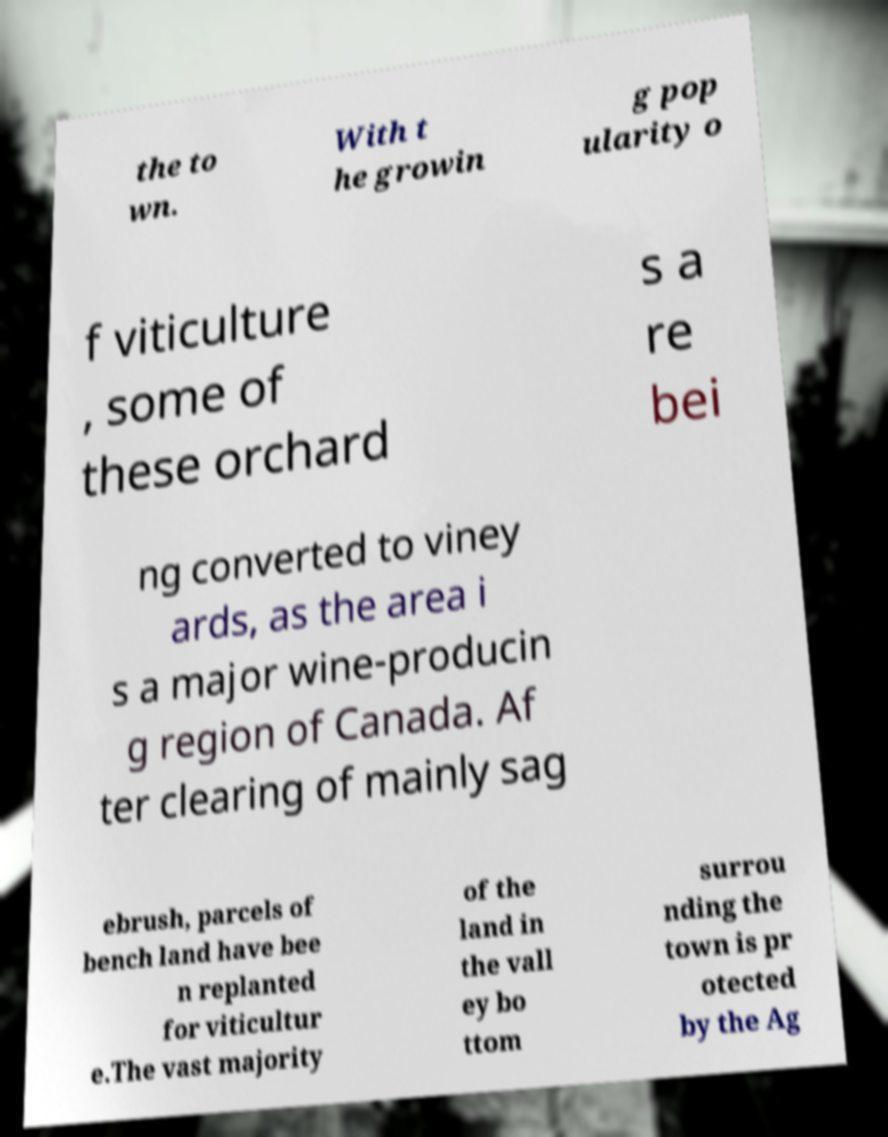Can you read and provide the text displayed in the image?This photo seems to have some interesting text. Can you extract and type it out for me? the to wn. With t he growin g pop ularity o f viticulture , some of these orchard s a re bei ng converted to viney ards, as the area i s a major wine-producin g region of Canada. Af ter clearing of mainly sag ebrush, parcels of bench land have bee n replanted for viticultur e.The vast majority of the land in the vall ey bo ttom surrou nding the town is pr otected by the Ag 